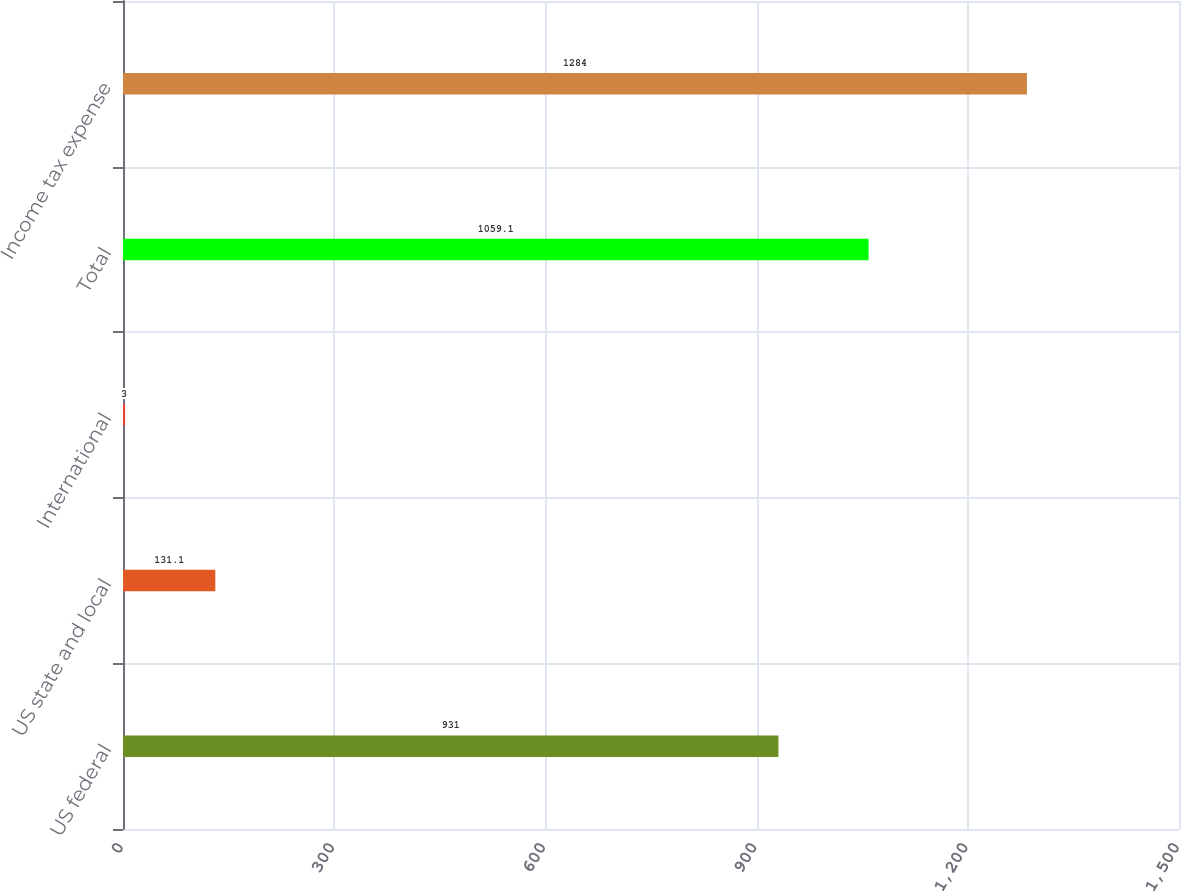Convert chart to OTSL. <chart><loc_0><loc_0><loc_500><loc_500><bar_chart><fcel>US federal<fcel>US state and local<fcel>International<fcel>Total<fcel>Income tax expense<nl><fcel>931<fcel>131.1<fcel>3<fcel>1059.1<fcel>1284<nl></chart> 